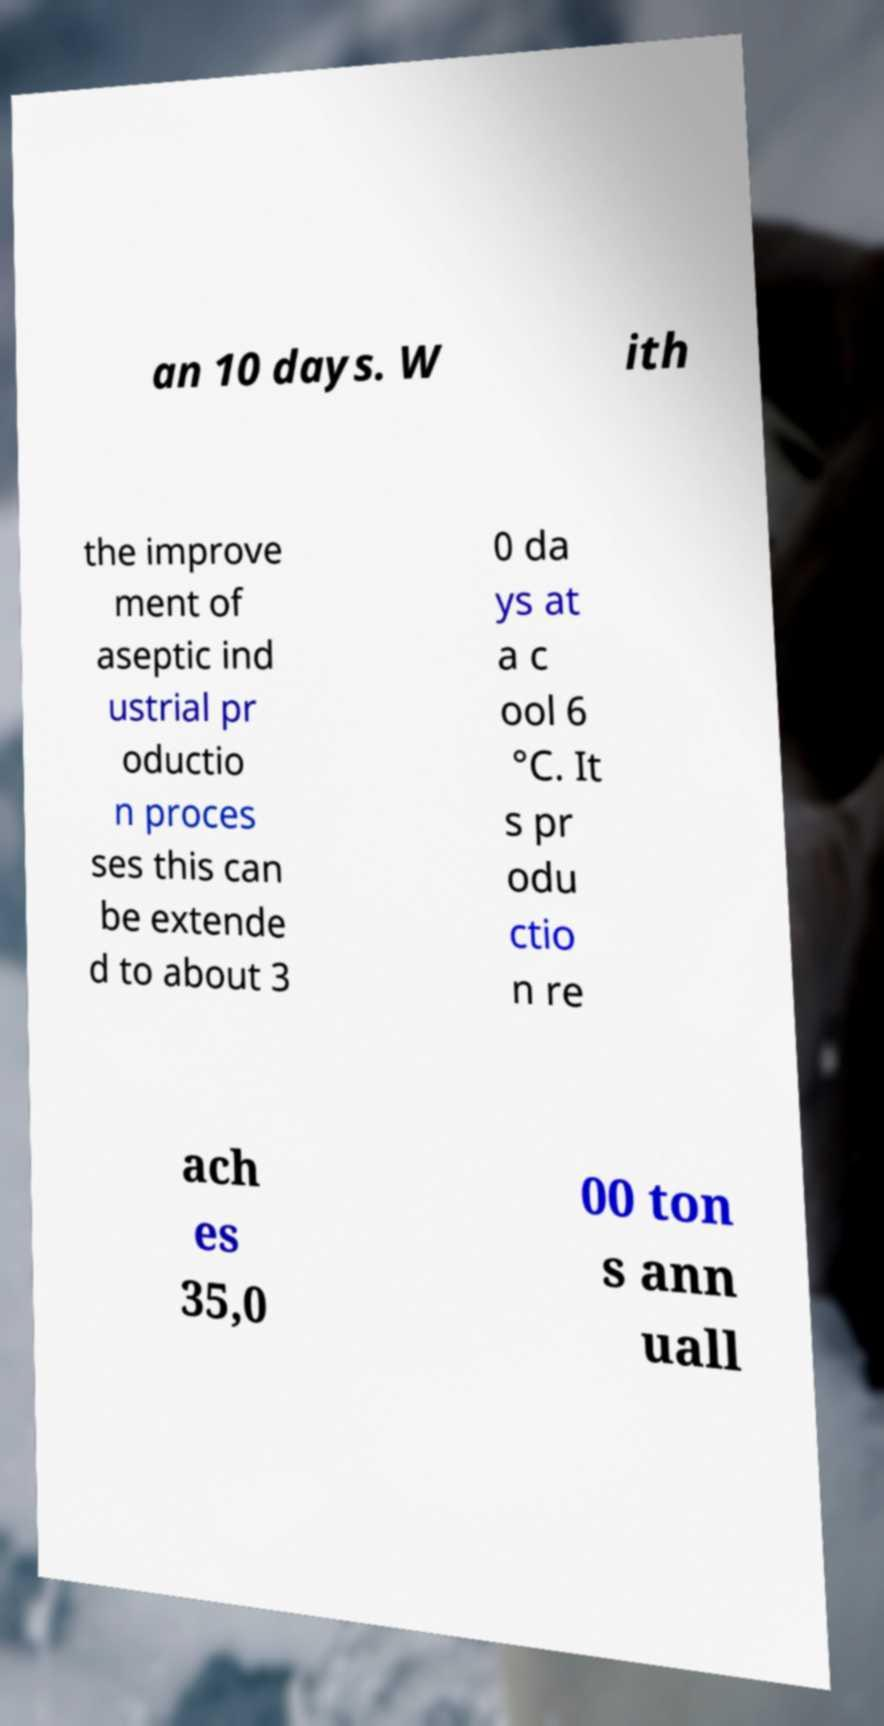What messages or text are displayed in this image? I need them in a readable, typed format. an 10 days. W ith the improve ment of aseptic ind ustrial pr oductio n proces ses this can be extende d to about 3 0 da ys at a c ool 6 °C. It s pr odu ctio n re ach es 35,0 00 ton s ann uall 